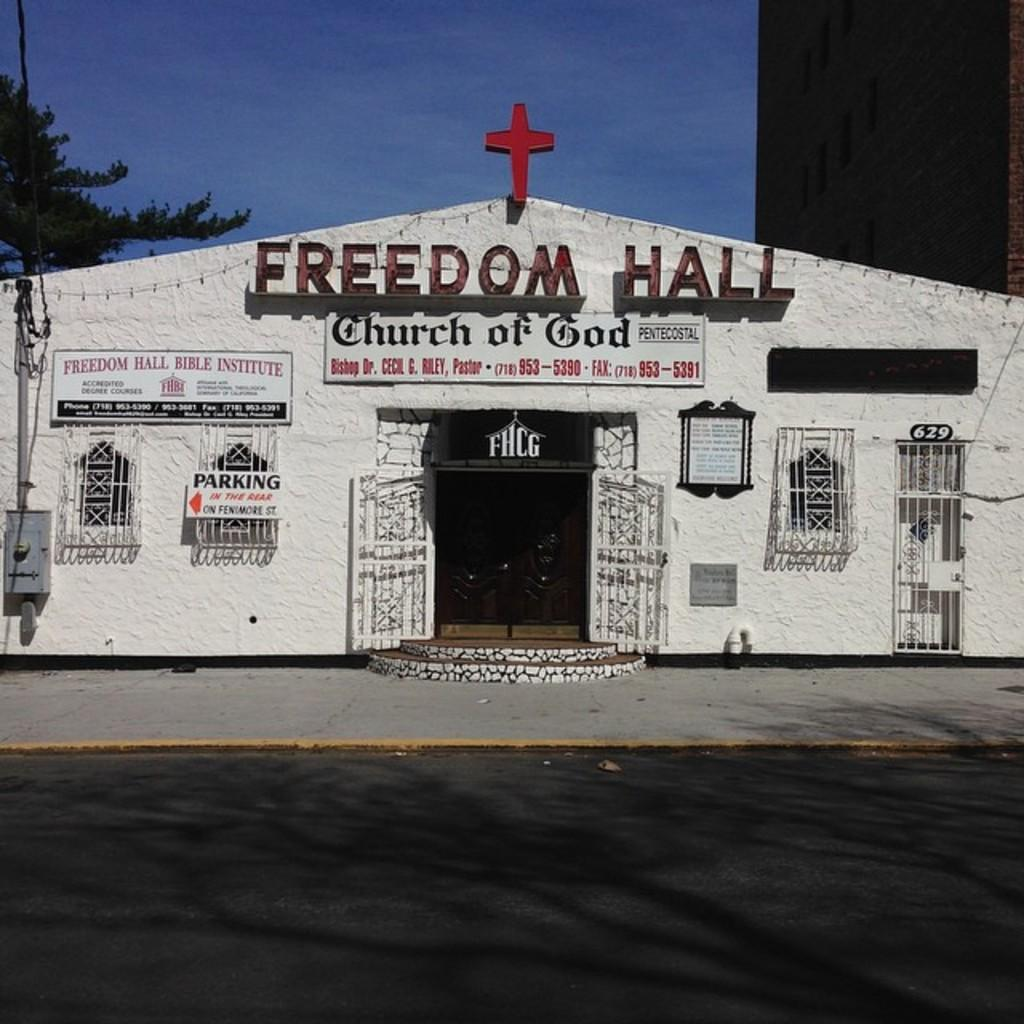What is the main structure in the image? There is a building in the image. What is attached to the building? There are banners on the building. What can be seen in the background of the image? There are trees and clouds visible in the background of the image. What part of the natural environment is visible in the image? The sky is visible in the background of the image. How many dinosaurs can be seen grazing in the background of the image? There are no dinosaurs present in the image; it features a building with banners and a background of trees and clouds. What type of needle is being used to expand the building in the image? There is no needle or expansion activity depicted in the image; it shows a building with banners and a background of trees and clouds. 